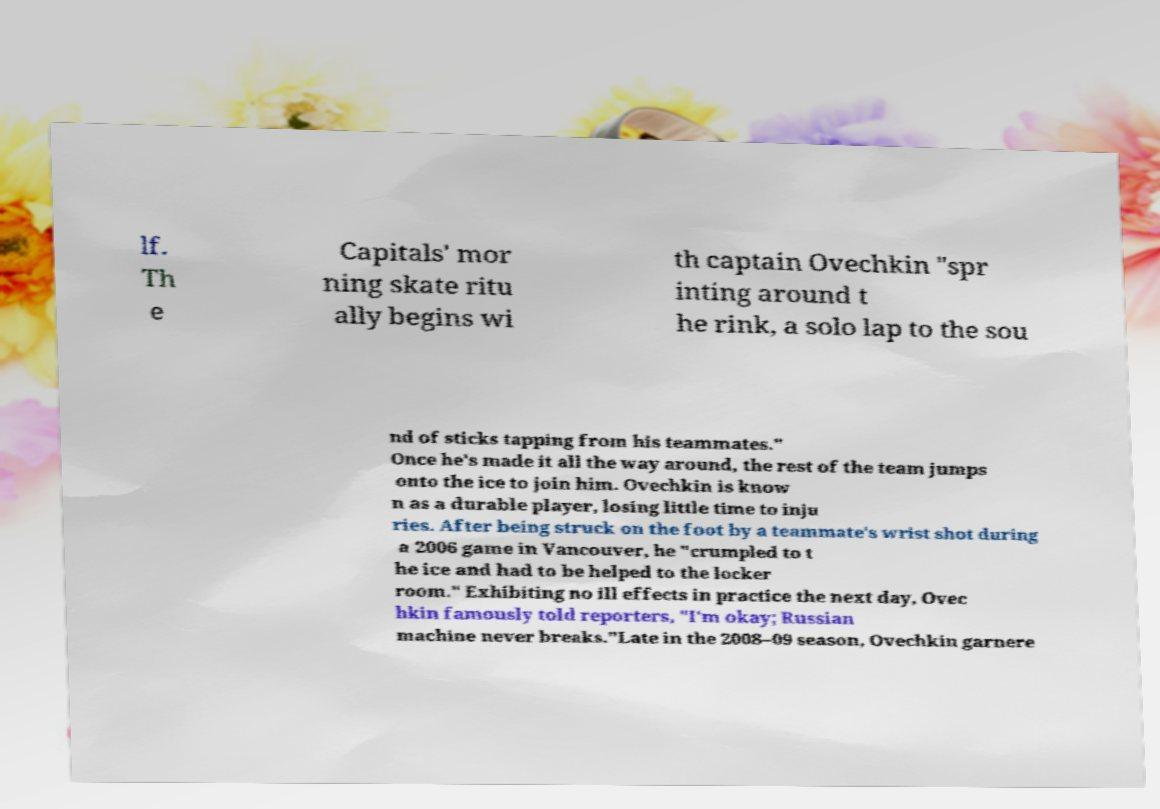Could you assist in decoding the text presented in this image and type it out clearly? lf. Th e Capitals' mor ning skate ritu ally begins wi th captain Ovechkin "spr inting around t he rink, a solo lap to the sou nd of sticks tapping from his teammates." Once he's made it all the way around, the rest of the team jumps onto the ice to join him. Ovechkin is know n as a durable player, losing little time to inju ries. After being struck on the foot by a teammate's wrist shot during a 2006 game in Vancouver, he "crumpled to t he ice and had to be helped to the locker room." Exhibiting no ill effects in practice the next day, Ovec hkin famously told reporters, "I'm okay; Russian machine never breaks."Late in the 2008–09 season, Ovechkin garnere 